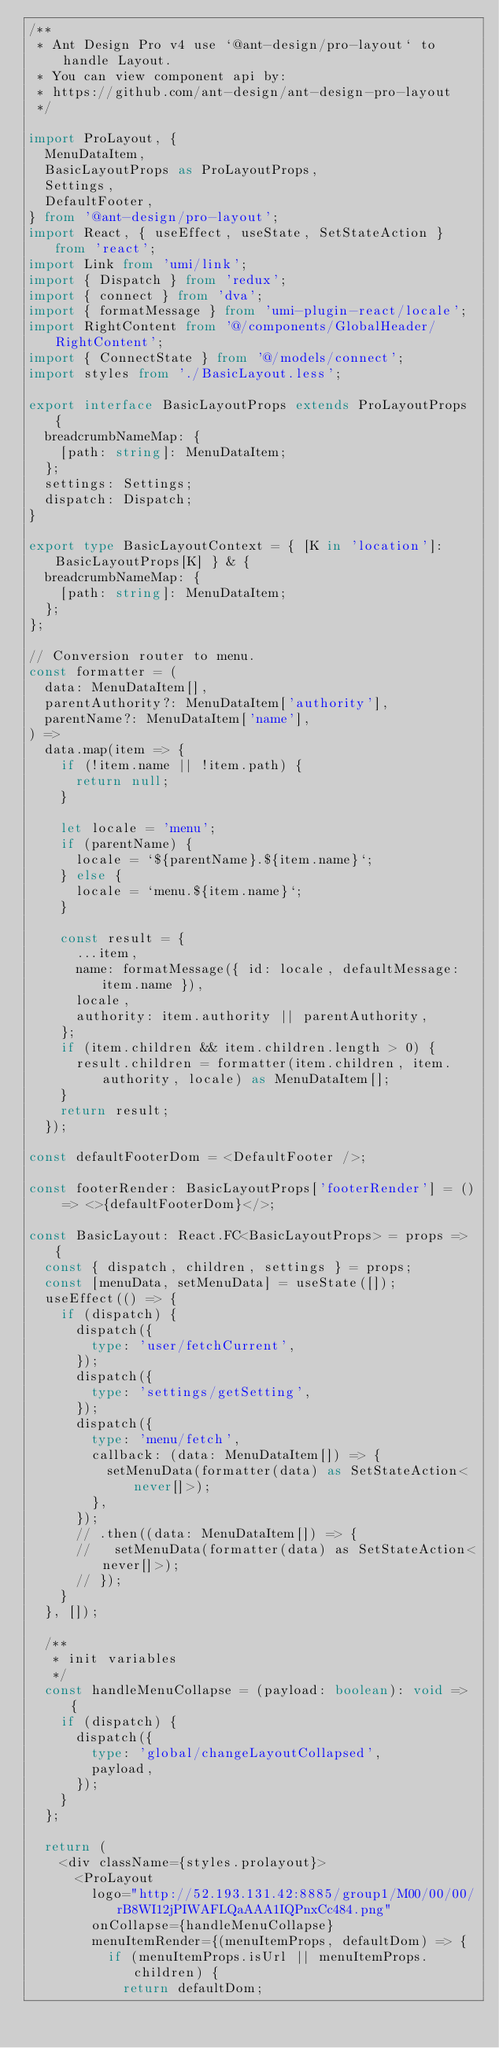<code> <loc_0><loc_0><loc_500><loc_500><_TypeScript_>/**
 * Ant Design Pro v4 use `@ant-design/pro-layout` to handle Layout.
 * You can view component api by:
 * https://github.com/ant-design/ant-design-pro-layout
 */

import ProLayout, {
  MenuDataItem,
  BasicLayoutProps as ProLayoutProps,
  Settings,
  DefaultFooter,
} from '@ant-design/pro-layout';
import React, { useEffect, useState, SetStateAction } from 'react';
import Link from 'umi/link';
import { Dispatch } from 'redux';
import { connect } from 'dva';
import { formatMessage } from 'umi-plugin-react/locale';
import RightContent from '@/components/GlobalHeader/RightContent';
import { ConnectState } from '@/models/connect';
import styles from './BasicLayout.less';

export interface BasicLayoutProps extends ProLayoutProps {
  breadcrumbNameMap: {
    [path: string]: MenuDataItem;
  };
  settings: Settings;
  dispatch: Dispatch;
}

export type BasicLayoutContext = { [K in 'location']: BasicLayoutProps[K] } & {
  breadcrumbNameMap: {
    [path: string]: MenuDataItem;
  };
};

// Conversion router to menu.
const formatter = (
  data: MenuDataItem[],
  parentAuthority?: MenuDataItem['authority'],
  parentName?: MenuDataItem['name'],
) =>
  data.map(item => {
    if (!item.name || !item.path) {
      return null;
    }

    let locale = 'menu';
    if (parentName) {
      locale = `${parentName}.${item.name}`;
    } else {
      locale = `menu.${item.name}`;
    }

    const result = {
      ...item,
      name: formatMessage({ id: locale, defaultMessage: item.name }),
      locale,
      authority: item.authority || parentAuthority,
    };
    if (item.children && item.children.length > 0) {
      result.children = formatter(item.children, item.authority, locale) as MenuDataItem[];
    }
    return result;
  });

const defaultFooterDom = <DefaultFooter />;

const footerRender: BasicLayoutProps['footerRender'] = () => <>{defaultFooterDom}</>;

const BasicLayout: React.FC<BasicLayoutProps> = props => {
  const { dispatch, children, settings } = props;
  const [menuData, setMenuData] = useState([]);
  useEffect(() => {
    if (dispatch) {
      dispatch({
        type: 'user/fetchCurrent',
      });
      dispatch({
        type: 'settings/getSetting',
      });
      dispatch({
        type: 'menu/fetch',
        callback: (data: MenuDataItem[]) => {
          setMenuData(formatter(data) as SetStateAction<never[]>);
        },
      });
      // .then((data: MenuDataItem[]) => {
      //   setMenuData(formatter(data) as SetStateAction<never[]>);
      // });
    }
  }, []);

  /**
   * init variables
   */
  const handleMenuCollapse = (payload: boolean): void => {
    if (dispatch) {
      dispatch({
        type: 'global/changeLayoutCollapsed',
        payload,
      });
    }
  };

  return (
    <div className={styles.prolayout}>
      <ProLayout
        logo="http://52.193.131.42:8885/group1/M00/00/00/rB8WI12jPIWAFLQaAAA1IQPnxCc484.png"
        onCollapse={handleMenuCollapse}
        menuItemRender={(menuItemProps, defaultDom) => {
          if (menuItemProps.isUrl || menuItemProps.children) {
            return defaultDom;</code> 